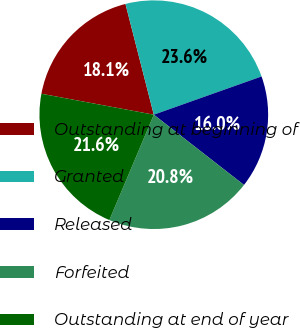Convert chart. <chart><loc_0><loc_0><loc_500><loc_500><pie_chart><fcel>Outstanding at beginning of<fcel>Granted<fcel>Released<fcel>Forfeited<fcel>Outstanding at end of year<nl><fcel>18.08%<fcel>23.56%<fcel>15.96%<fcel>20.82%<fcel>21.58%<nl></chart> 